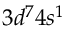<formula> <loc_0><loc_0><loc_500><loc_500>3 d ^ { 7 } 4 s ^ { 1 }</formula> 